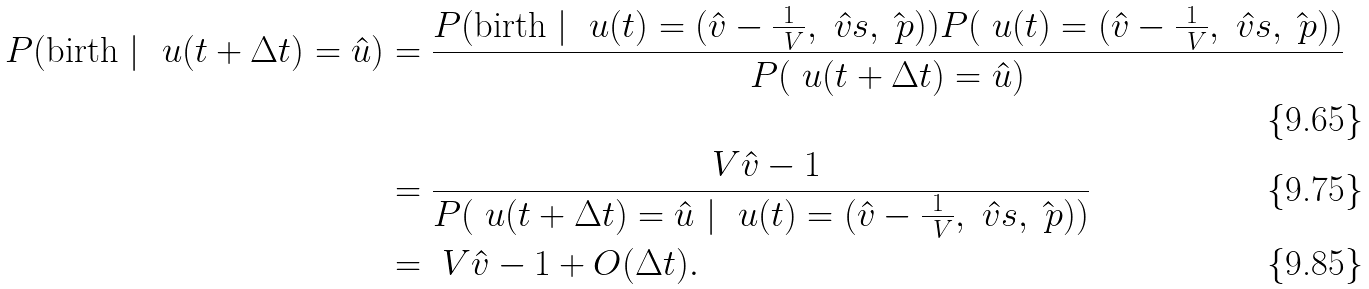<formula> <loc_0><loc_0><loc_500><loc_500>P ( \text {birth} \ | \ \ u ( t + \Delta t ) = \hat { u } ) & = \frac { P ( \text {birth} \ | \ \ u ( t ) = ( \hat { v } - \frac { 1 } { \ V } , \hat { \ v s } , \hat { \ p } ) ) P ( \ u ( t ) = ( \hat { v } - \frac { 1 } { \ V } , \hat { \ v s } , \hat { \ p } ) ) } { P ( \ u ( t + \Delta t ) = \hat { u } ) } \\ & = \frac { \ V \hat { v } - 1 } { P ( \ u ( t + \Delta t ) = \hat { u } \ | \ \ u ( t ) = ( \hat { v } - \frac { 1 } { \ V } , \hat { \ v s } , \hat { \ p } ) ) } \\ & = \ V \hat { v } - 1 + O ( \Delta t ) .</formula> 